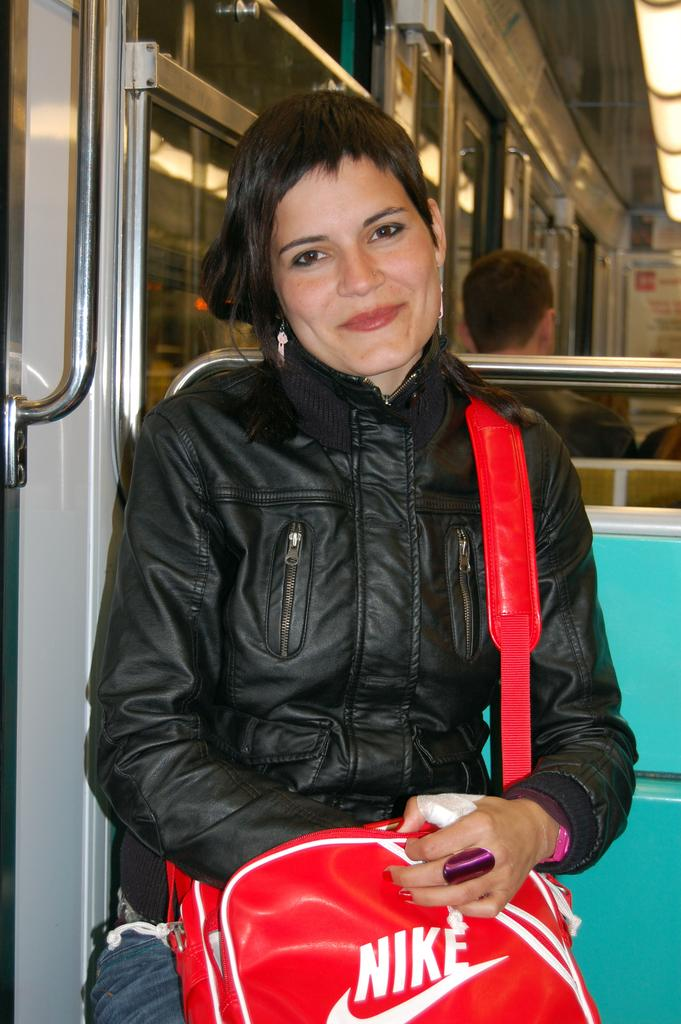<image>
Offer a succinct explanation of the picture presented. A woman is carrying a bag with a Nike logo on it. 